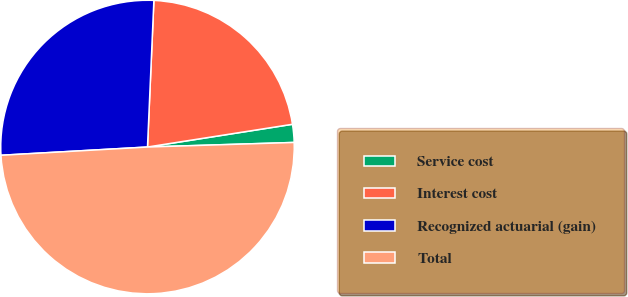Convert chart. <chart><loc_0><loc_0><loc_500><loc_500><pie_chart><fcel>Service cost<fcel>Interest cost<fcel>Recognized actuarial (gain)<fcel>Total<nl><fcel>1.98%<fcel>21.83%<fcel>26.59%<fcel>49.6%<nl></chart> 